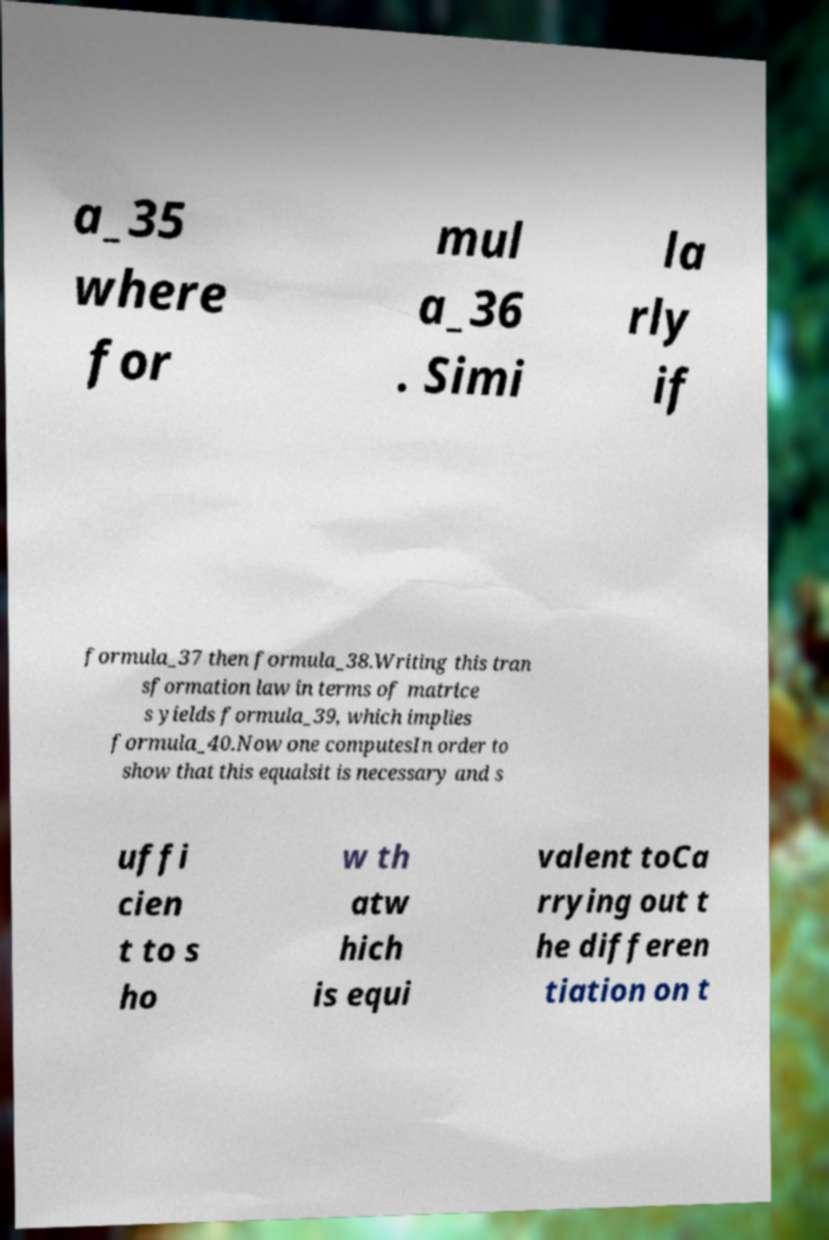For documentation purposes, I need the text within this image transcribed. Could you provide that? a_35 where for mul a_36 . Simi la rly if formula_37 then formula_38.Writing this tran sformation law in terms of matrice s yields formula_39, which implies formula_40.Now one computesIn order to show that this equalsit is necessary and s uffi cien t to s ho w th atw hich is equi valent toCa rrying out t he differen tiation on t 